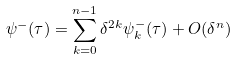Convert formula to latex. <formula><loc_0><loc_0><loc_500><loc_500>\psi ^ { - } ( \tau ) = \sum _ { k = 0 } ^ { n - 1 } \delta ^ { 2 k } \psi _ { k } ^ { - } ( \tau ) + O ( \delta ^ { n } )</formula> 